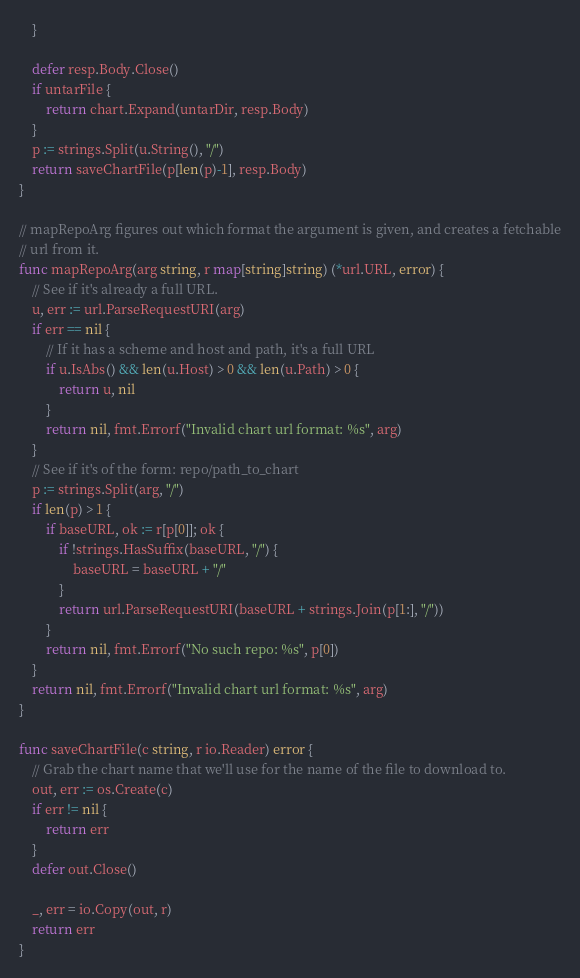<code> <loc_0><loc_0><loc_500><loc_500><_Go_>	}

	defer resp.Body.Close()
	if untarFile {
		return chart.Expand(untarDir, resp.Body)
	}
	p := strings.Split(u.String(), "/")
	return saveChartFile(p[len(p)-1], resp.Body)
}

// mapRepoArg figures out which format the argument is given, and creates a fetchable
// url from it.
func mapRepoArg(arg string, r map[string]string) (*url.URL, error) {
	// See if it's already a full URL.
	u, err := url.ParseRequestURI(arg)
	if err == nil {
		// If it has a scheme and host and path, it's a full URL
		if u.IsAbs() && len(u.Host) > 0 && len(u.Path) > 0 {
			return u, nil
		}
		return nil, fmt.Errorf("Invalid chart url format: %s", arg)
	}
	// See if it's of the form: repo/path_to_chart
	p := strings.Split(arg, "/")
	if len(p) > 1 {
		if baseURL, ok := r[p[0]]; ok {
			if !strings.HasSuffix(baseURL, "/") {
				baseURL = baseURL + "/"
			}
			return url.ParseRequestURI(baseURL + strings.Join(p[1:], "/"))
		}
		return nil, fmt.Errorf("No such repo: %s", p[0])
	}
	return nil, fmt.Errorf("Invalid chart url format: %s", arg)
}

func saveChartFile(c string, r io.Reader) error {
	// Grab the chart name that we'll use for the name of the file to download to.
	out, err := os.Create(c)
	if err != nil {
		return err
	}
	defer out.Close()

	_, err = io.Copy(out, r)
	return err
}
</code> 